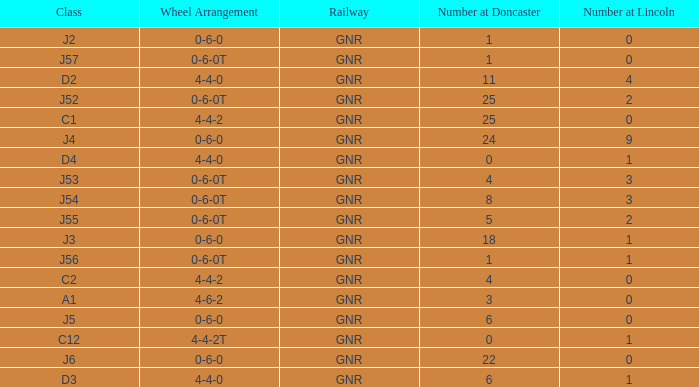Which Class has a Number at Lincoln larger than 0 and a Number at Doncaster of 8? J54. Can you parse all the data within this table? {'header': ['Class', 'Wheel Arrangement', 'Railway', 'Number at Doncaster', 'Number at Lincoln'], 'rows': [['J2', '0-6-0', 'GNR', '1', '0'], ['J57', '0-6-0T', 'GNR', '1', '0'], ['D2', '4-4-0', 'GNR', '11', '4'], ['J52', '0-6-0T', 'GNR', '25', '2'], ['C1', '4-4-2', 'GNR', '25', '0'], ['J4', '0-6-0', 'GNR', '24', '9'], ['D4', '4-4-0', 'GNR', '0', '1'], ['J53', '0-6-0T', 'GNR', '4', '3'], ['J54', '0-6-0T', 'GNR', '8', '3'], ['J55', '0-6-0T', 'GNR', '5', '2'], ['J3', '0-6-0', 'GNR', '18', '1'], ['J56', '0-6-0T', 'GNR', '1', '1'], ['C2', '4-4-2', 'GNR', '4', '0'], ['A1', '4-6-2', 'GNR', '3', '0'], ['J5', '0-6-0', 'GNR', '6', '0'], ['C12', '4-4-2T', 'GNR', '0', '1'], ['J6', '0-6-0', 'GNR', '22', '0'], ['D3', '4-4-0', 'GNR', '6', '1']]} 